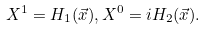Convert formula to latex. <formula><loc_0><loc_0><loc_500><loc_500>X ^ { 1 } = H _ { 1 } ( \vec { x } ) , X ^ { 0 } = i H _ { 2 } ( \vec { x } ) .</formula> 